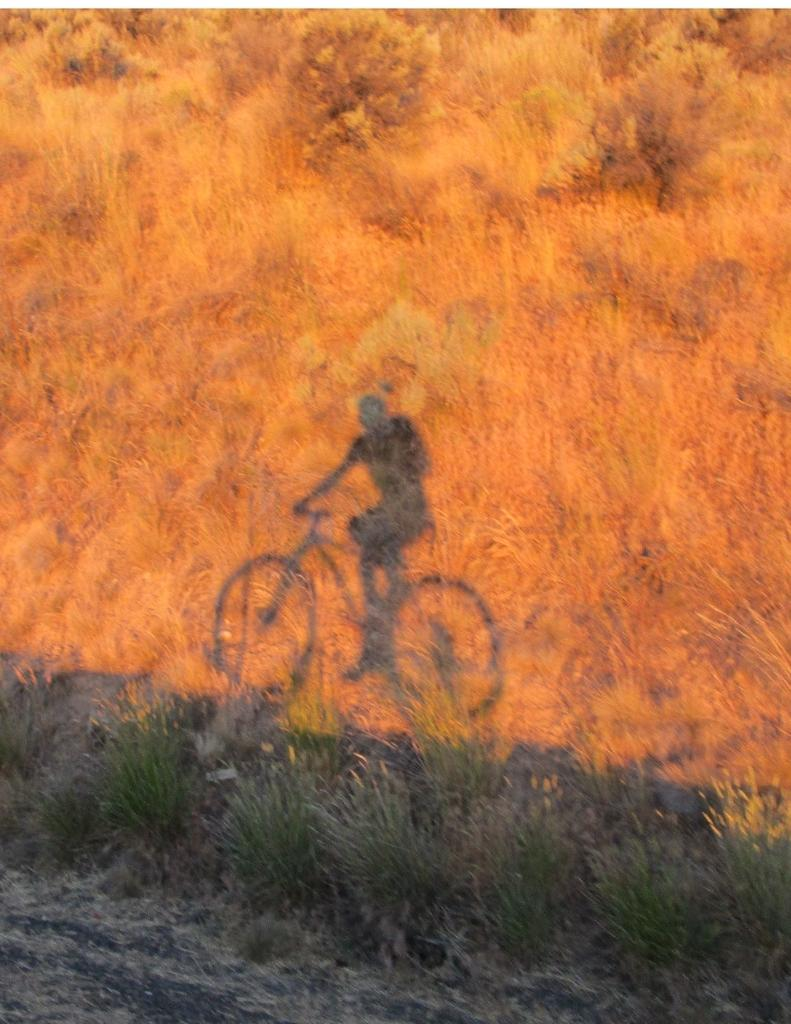What can be seen in the image through the shadows? There are shadows of a person and a bicycle in the image. What type of surface is visible in the image? There is grass visible in the image. What type of egg is being used as a table in the image? There is no egg or table present in the image. 